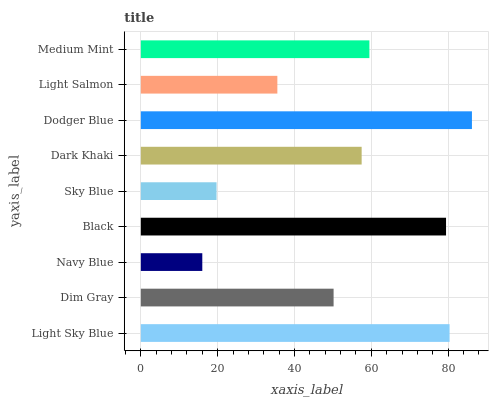Is Navy Blue the minimum?
Answer yes or no. Yes. Is Dodger Blue the maximum?
Answer yes or no. Yes. Is Dim Gray the minimum?
Answer yes or no. No. Is Dim Gray the maximum?
Answer yes or no. No. Is Light Sky Blue greater than Dim Gray?
Answer yes or no. Yes. Is Dim Gray less than Light Sky Blue?
Answer yes or no. Yes. Is Dim Gray greater than Light Sky Blue?
Answer yes or no. No. Is Light Sky Blue less than Dim Gray?
Answer yes or no. No. Is Dark Khaki the high median?
Answer yes or no. Yes. Is Dark Khaki the low median?
Answer yes or no. Yes. Is Black the high median?
Answer yes or no. No. Is Dodger Blue the low median?
Answer yes or no. No. 